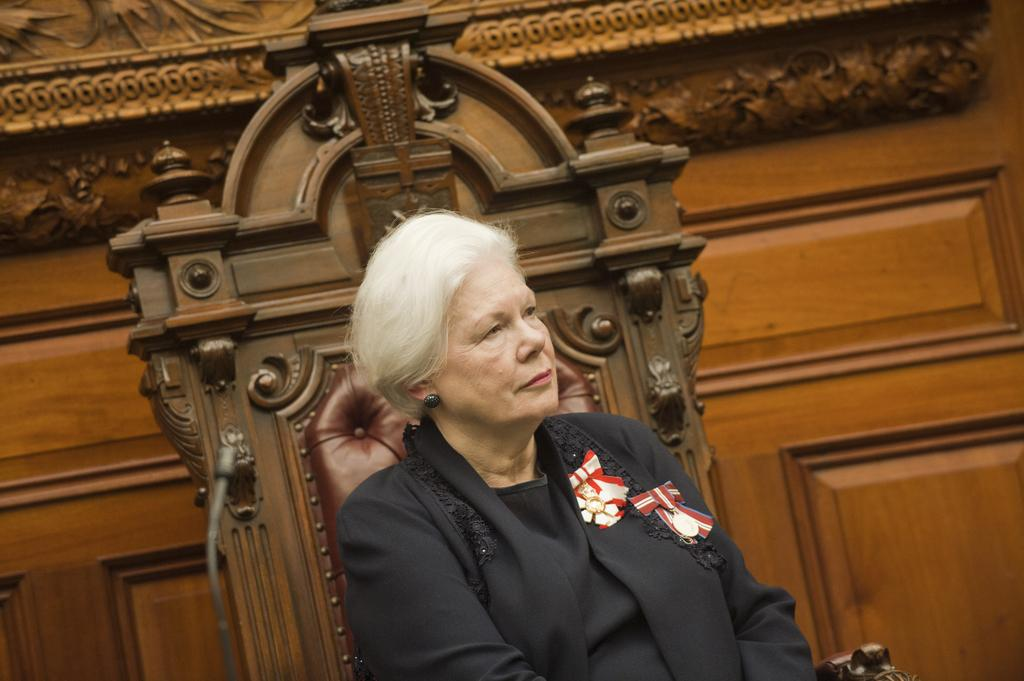What is present in the image? There is a person in the image. What is the person wearing? The person is wearing clothes. What is the person doing in the image? The person is sitting on a chair. What type of worm can be seen crawling on the person's clothes in the image? There is no worm present in the image; the person is wearing clothes without any visible worms. 